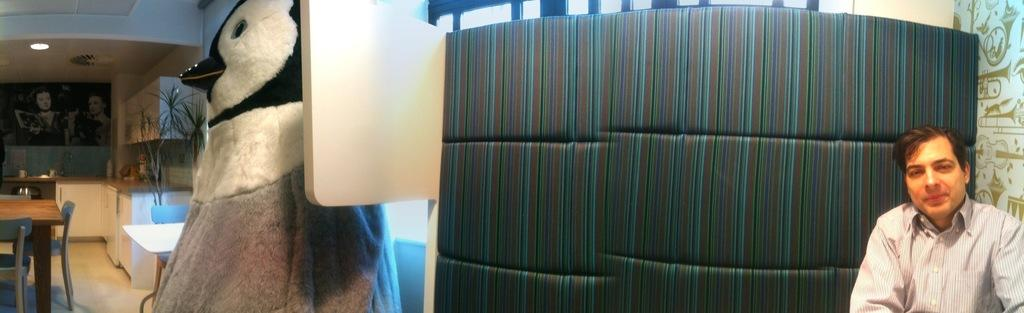Who is present in the image? There is a man in the image. What object can be seen in the image that is typically associated with play? There is a toy in the image. What type of furniture is visible in the image? There are tables, chairs, and cupboards in the image. What is the purpose of the wash basin in the image? The wash basin is likely used for washing hands or other cleaning purposes. What type of plant is present in the image? There is a plant in the image. What source of illumination is visible in the image? There is a light in the image. What architectural feature is present in the image? There is a ceiling in the image. What type of decoration is present on the wall in the image? There are pictures on the wall in the image. What type of snail can be seen crawling on the ceiling in the image? There is no snail present in the image; it only features a man, toy, furniture, wash basin, plant, light, ceiling, and pictures on the wall. 